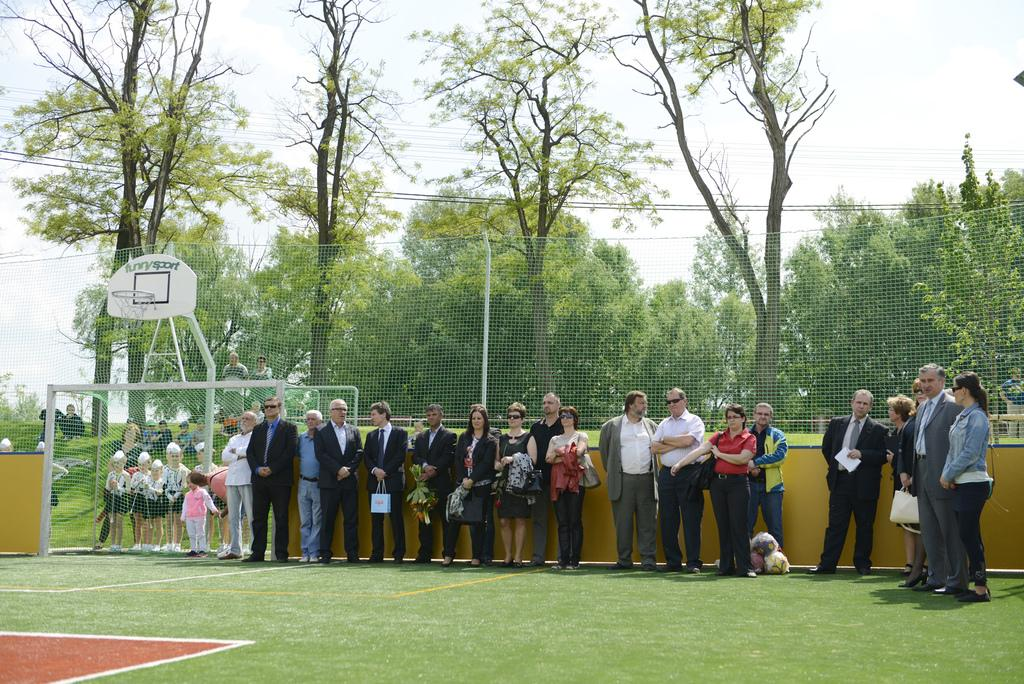What is the main subject of the image? The main subject of the image is a group of persons standing in the center. Where are the persons standing? The group of persons is standing on the ground. What can be seen in the background of the image? In the background, there is a net, a pole, trees, the sky, grass, and additional persons. How many trees are visible in the background? There are more than one tree visible in the background. What type of oil can be seen dripping from the thumb of one of the persons in the image? There is no oil or thumb visible in the image; it only features a group of persons standing on the ground and various elements in the background. How many passengers are visible in the image? There is no reference to passengers in the image; it only features a group of persons standing on the ground and various elements in the background. 